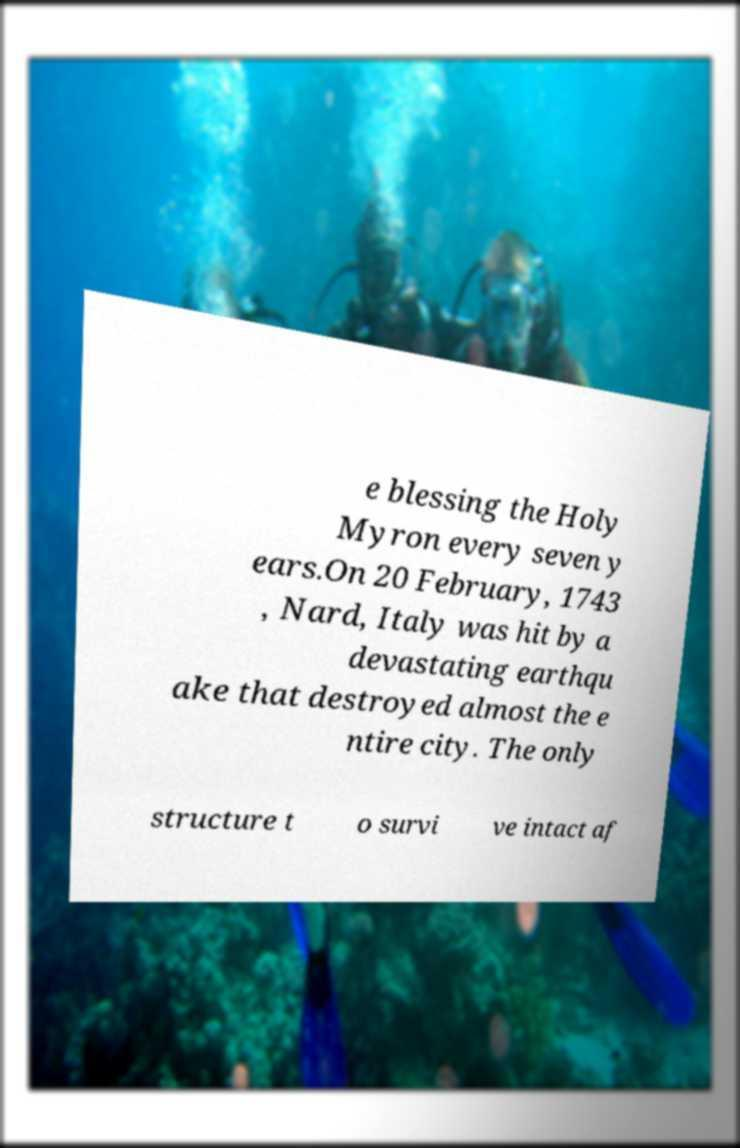What messages or text are displayed in this image? I need them in a readable, typed format. e blessing the Holy Myron every seven y ears.On 20 February, 1743 , Nard, Italy was hit by a devastating earthqu ake that destroyed almost the e ntire city. The only structure t o survi ve intact af 